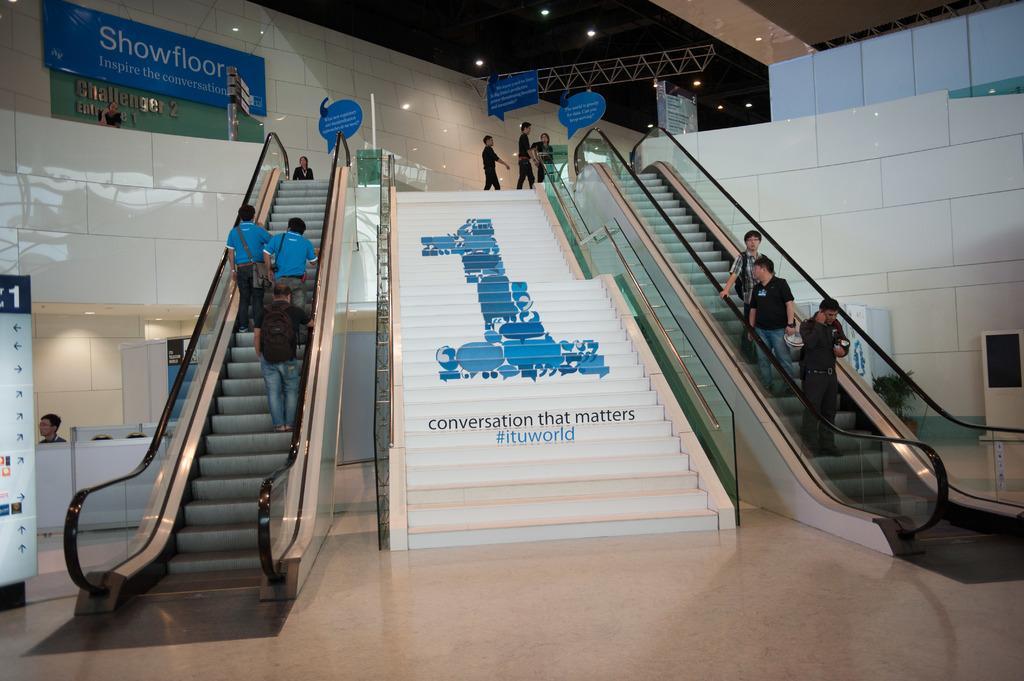How would you summarize this image in a sentence or two? In this image, I can see six persons standing on the escalators and three persons walking. In the center of the image, it looks like a sticker and words on a stairway. At the bottom of the image, there is a floor. On the right side of the image, I can see a house plant, a table and an object. On the left side of the image, I can see a board with directions and there is a person behind the table. At the top of the image, there are ceiling lights, a truss and boards. 